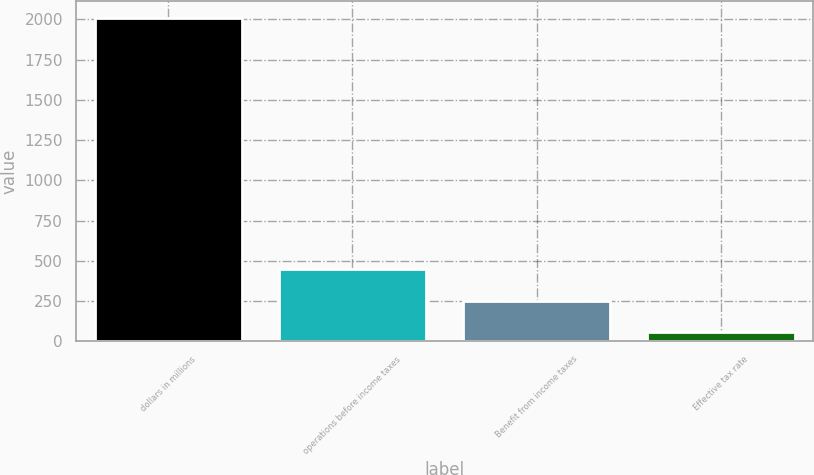Convert chart to OTSL. <chart><loc_0><loc_0><loc_500><loc_500><bar_chart><fcel>dollars in millions<fcel>operations before income taxes<fcel>Benefit from income taxes<fcel>Effective tax rate<nl><fcel>2012<fcel>446.56<fcel>250.88<fcel>55.2<nl></chart> 